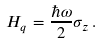<formula> <loc_0><loc_0><loc_500><loc_500>H _ { q } = \frac { \hbar { \omega } } { 2 } \sigma _ { z } \, .</formula> 